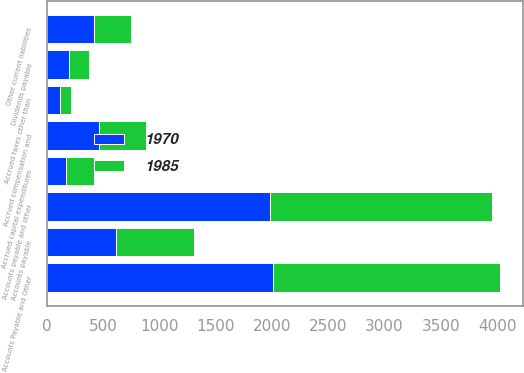<chart> <loc_0><loc_0><loc_500><loc_500><stacked_bar_chart><ecel><fcel>Accounts Payable and Other<fcel>Accounts payable<fcel>Accrued capital expenditures<fcel>Accrued compensation and<fcel>Dividends payable<fcel>Accrued taxes other than<fcel>Other current liabilities<fcel>Accounts payable and other<nl><fcel>1970<fcel>2015<fcel>616<fcel>174<fcel>465<fcel>197<fcel>116<fcel>417<fcel>1985<nl><fcel>1985<fcel>2014<fcel>694<fcel>250<fcel>419<fcel>178<fcel>100<fcel>329<fcel>1970<nl></chart> 